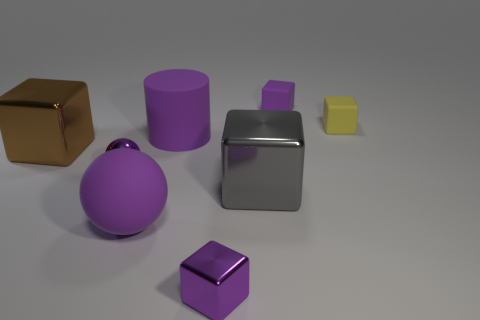Is the large matte sphere the same color as the small metal ball?
Ensure brevity in your answer.  Yes. What is the material of the other ball that is the same color as the big matte ball?
Ensure brevity in your answer.  Metal. What number of other objects are the same shape as the yellow matte thing?
Give a very brief answer. 4. Do the big brown thing and the big metallic thing in front of the brown cube have the same shape?
Provide a short and direct response. Yes. There is a small purple metal sphere; how many tiny shiny objects are right of it?
Ensure brevity in your answer.  1. There is a large purple object in front of the gray metal object; is its shape the same as the tiny yellow rubber object?
Provide a succinct answer. No. There is a matte block left of the yellow object; what is its color?
Your answer should be compact. Purple. There is a big brown thing that is made of the same material as the gray object; what shape is it?
Provide a short and direct response. Cube. Is there anything else of the same color as the rubber sphere?
Your response must be concise. Yes. Is the number of small cubes right of the large purple matte sphere greater than the number of small blocks on the left side of the large purple matte cylinder?
Your response must be concise. Yes. 